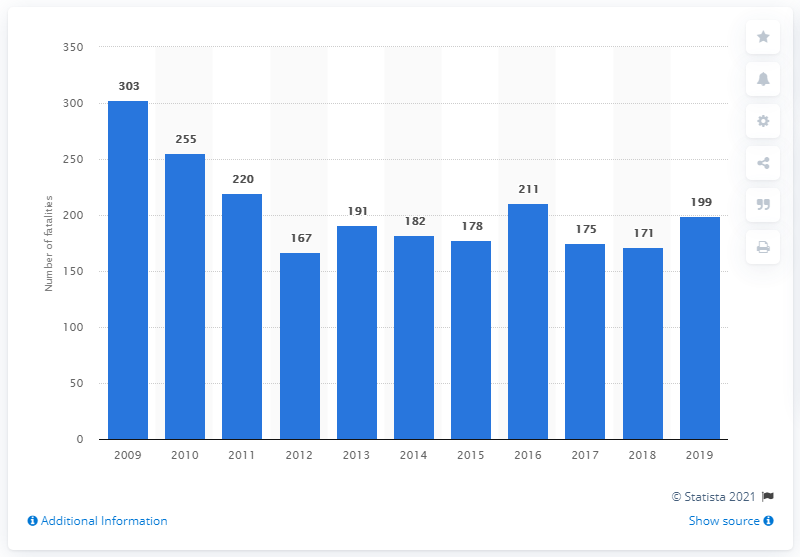Identify some key points in this picture. There were 303 deaths in traffic accidents between 2009 and 2019. A total of 199 traffic fatalities were recorded in Denmark in 2019. 